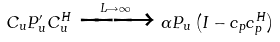Convert formula to latex. <formula><loc_0><loc_0><loc_500><loc_500>C _ { u } P _ { u } ^ { \prime } C _ { u } ^ { H } \xrightarrow [ ] { L \rightarrow \infty } \alpha P _ { u } \left ( I - c _ { p } c _ { p } ^ { H } \right )</formula> 